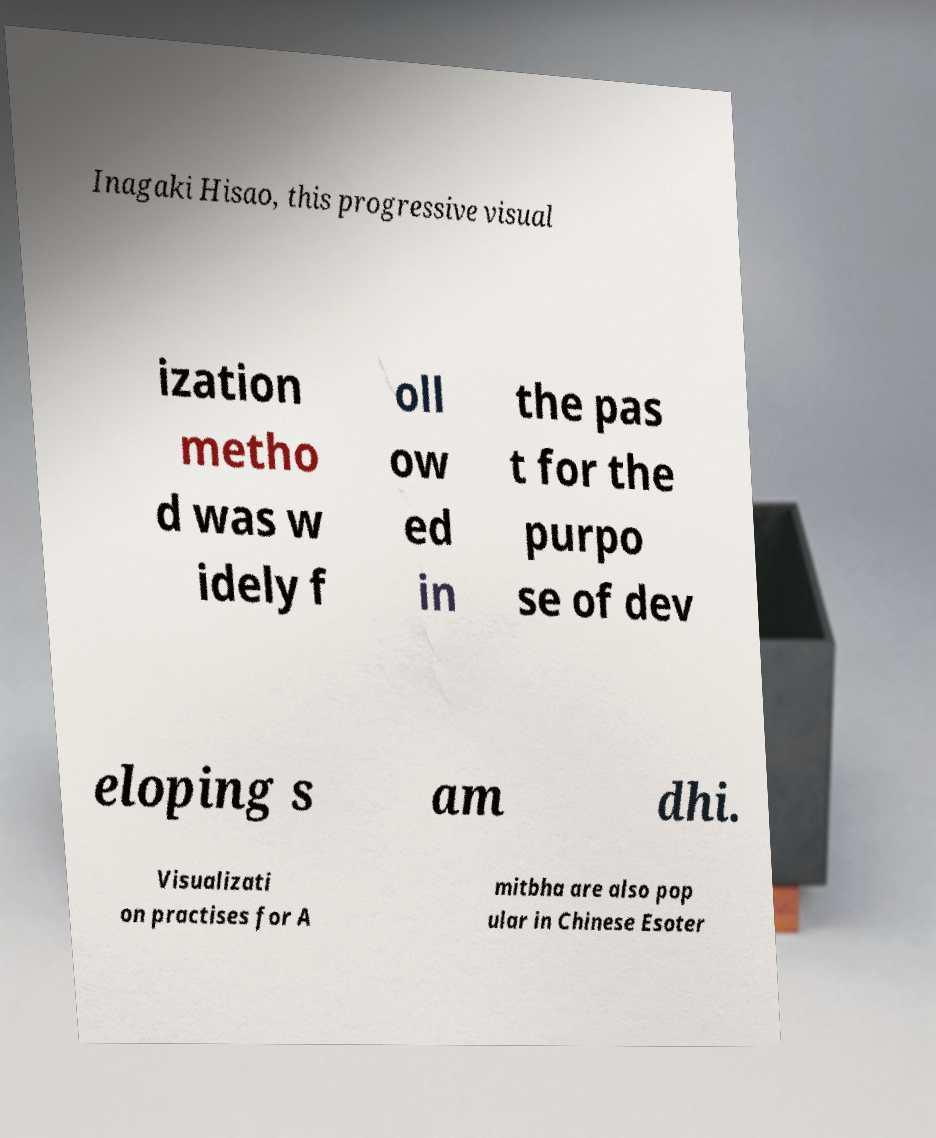Please read and relay the text visible in this image. What does it say? Inagaki Hisao, this progressive visual ization metho d was w idely f oll ow ed in the pas t for the purpo se of dev eloping s am dhi. Visualizati on practises for A mitbha are also pop ular in Chinese Esoter 